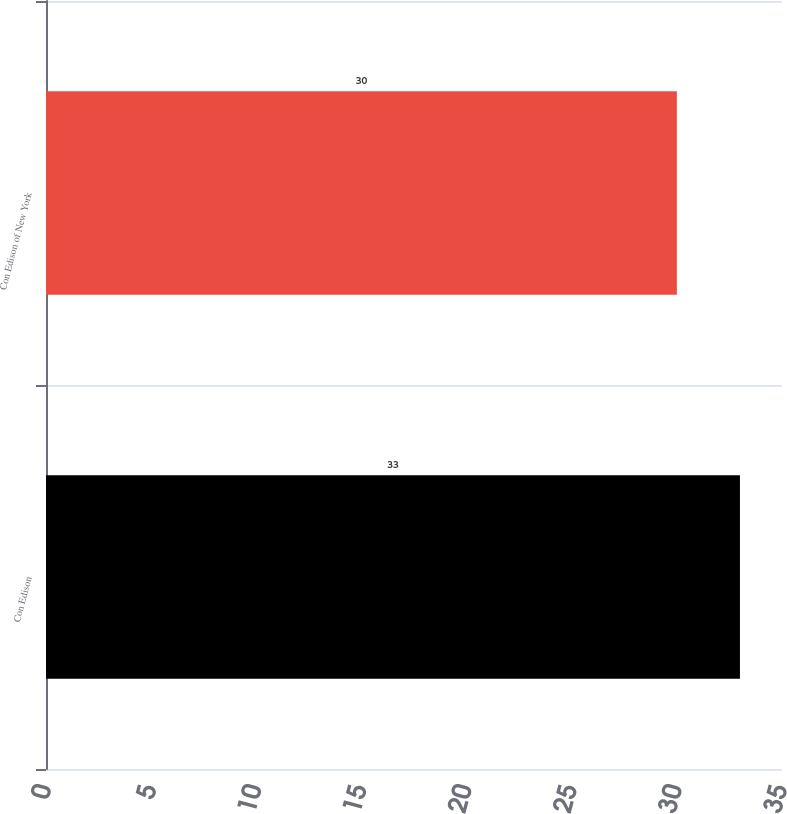<chart> <loc_0><loc_0><loc_500><loc_500><bar_chart><fcel>Con Edison<fcel>Con Edison of New York<nl><fcel>33<fcel>30<nl></chart> 